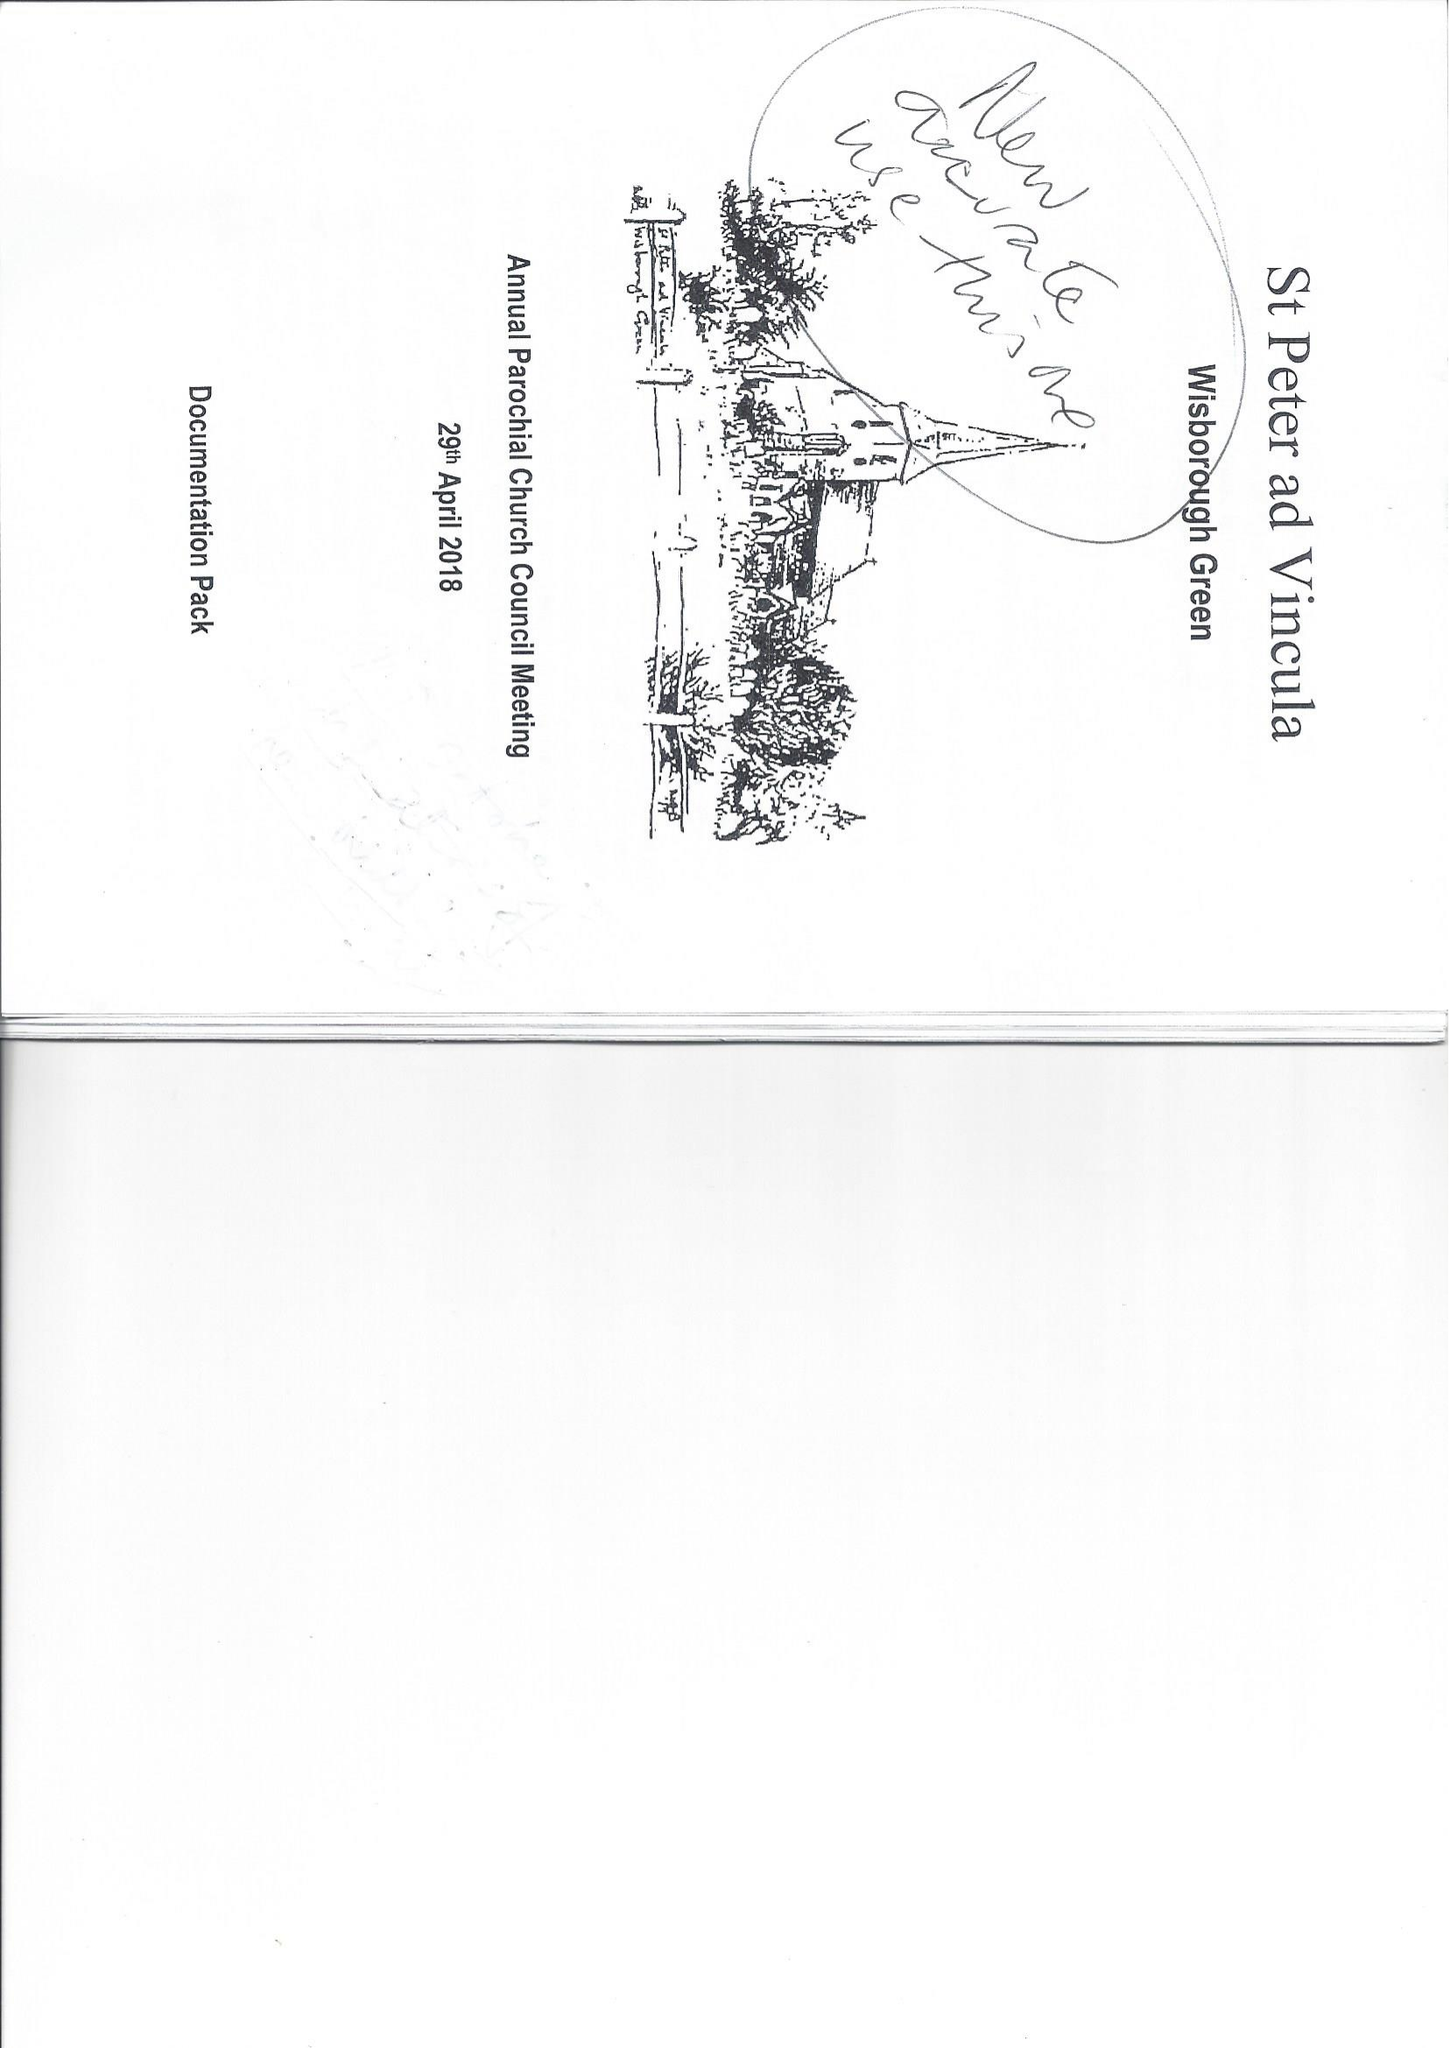What is the value for the address__postcode?
Answer the question using a single word or phrase. RH14 0AQ 